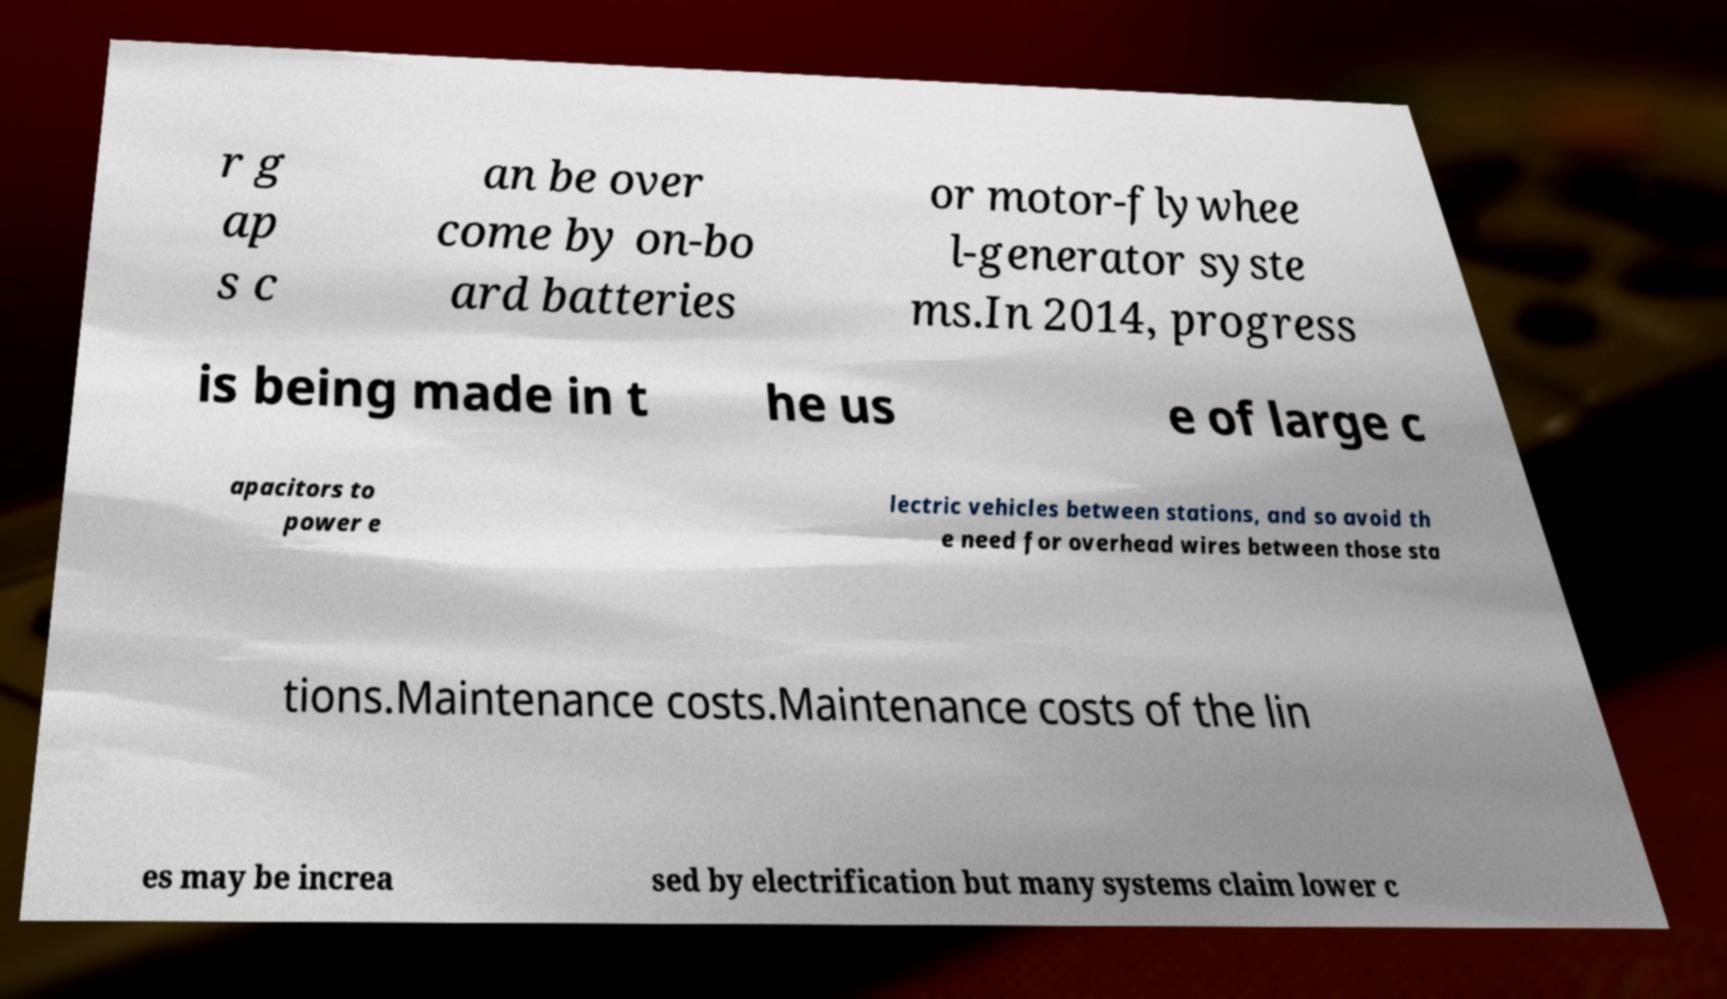There's text embedded in this image that I need extracted. Can you transcribe it verbatim? r g ap s c an be over come by on-bo ard batteries or motor-flywhee l-generator syste ms.In 2014, progress is being made in t he us e of large c apacitors to power e lectric vehicles between stations, and so avoid th e need for overhead wires between those sta tions.Maintenance costs.Maintenance costs of the lin es may be increa sed by electrification but many systems claim lower c 